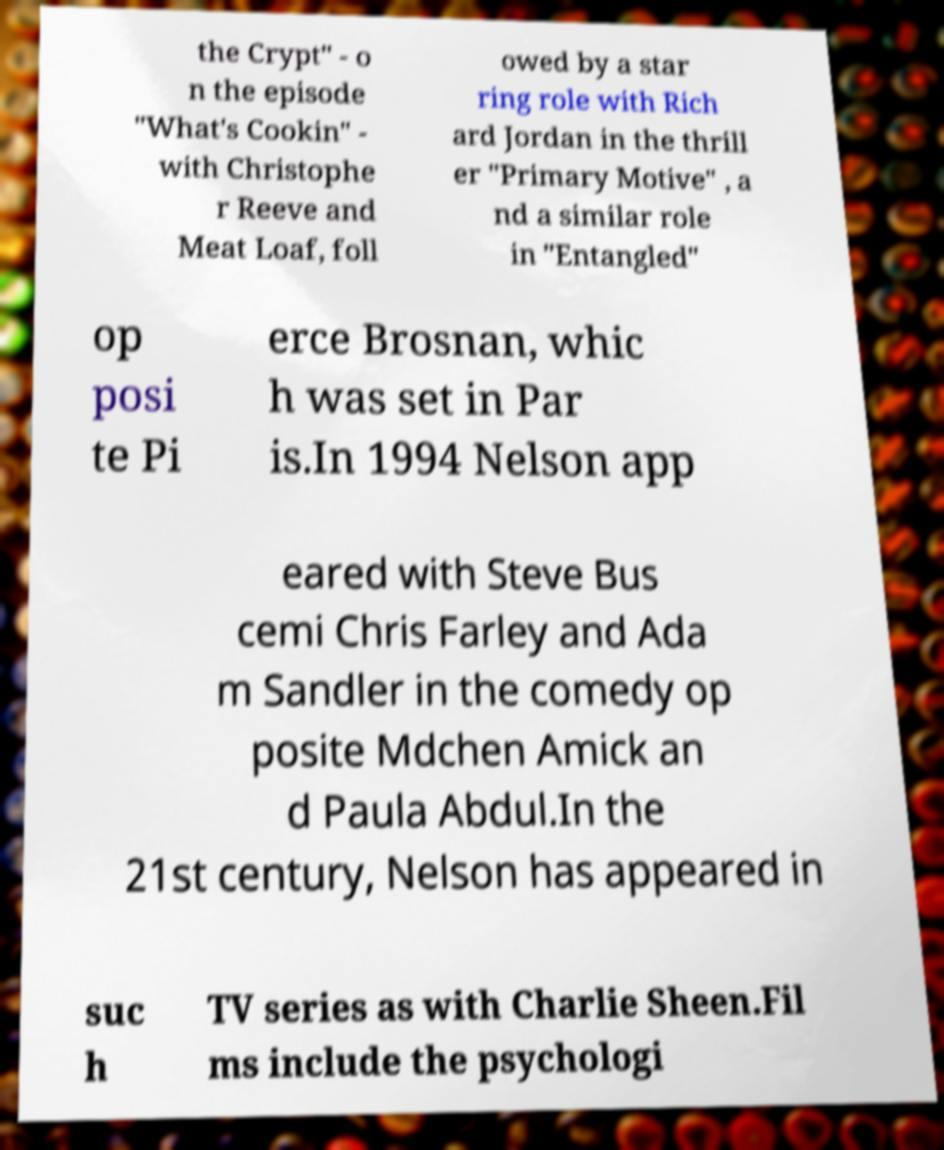Could you assist in decoding the text presented in this image and type it out clearly? the Crypt" - o n the episode "What's Cookin" - with Christophe r Reeve and Meat Loaf, foll owed by a star ring role with Rich ard Jordan in the thrill er "Primary Motive" , a nd a similar role in "Entangled" op posi te Pi erce Brosnan, whic h was set in Par is.In 1994 Nelson app eared with Steve Bus cemi Chris Farley and Ada m Sandler in the comedy op posite Mdchen Amick an d Paula Abdul.In the 21st century, Nelson has appeared in suc h TV series as with Charlie Sheen.Fil ms include the psychologi 